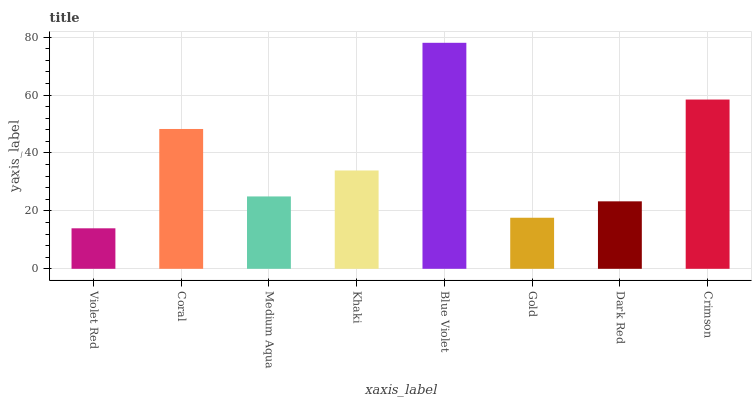Is Violet Red the minimum?
Answer yes or no. Yes. Is Blue Violet the maximum?
Answer yes or no. Yes. Is Coral the minimum?
Answer yes or no. No. Is Coral the maximum?
Answer yes or no. No. Is Coral greater than Violet Red?
Answer yes or no. Yes. Is Violet Red less than Coral?
Answer yes or no. Yes. Is Violet Red greater than Coral?
Answer yes or no. No. Is Coral less than Violet Red?
Answer yes or no. No. Is Khaki the high median?
Answer yes or no. Yes. Is Medium Aqua the low median?
Answer yes or no. Yes. Is Medium Aqua the high median?
Answer yes or no. No. Is Gold the low median?
Answer yes or no. No. 